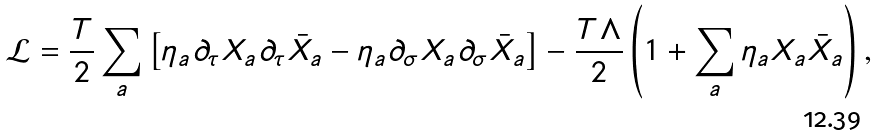Convert formula to latex. <formula><loc_0><loc_0><loc_500><loc_500>\mathcal { L } = \frac { T } { 2 } \sum _ { a } \left [ \eta _ { a } \partial _ { \tau } X _ { a } \partial _ { \tau } \bar { X } _ { a } - \eta _ { a } \partial _ { \sigma } X _ { a } \partial _ { \sigma } \bar { X } _ { a } \right ] - \frac { T \Lambda } { 2 } \left ( 1 + \sum _ { a } \eta _ { a } X _ { a } \bar { X } _ { a } \right ) ,</formula> 